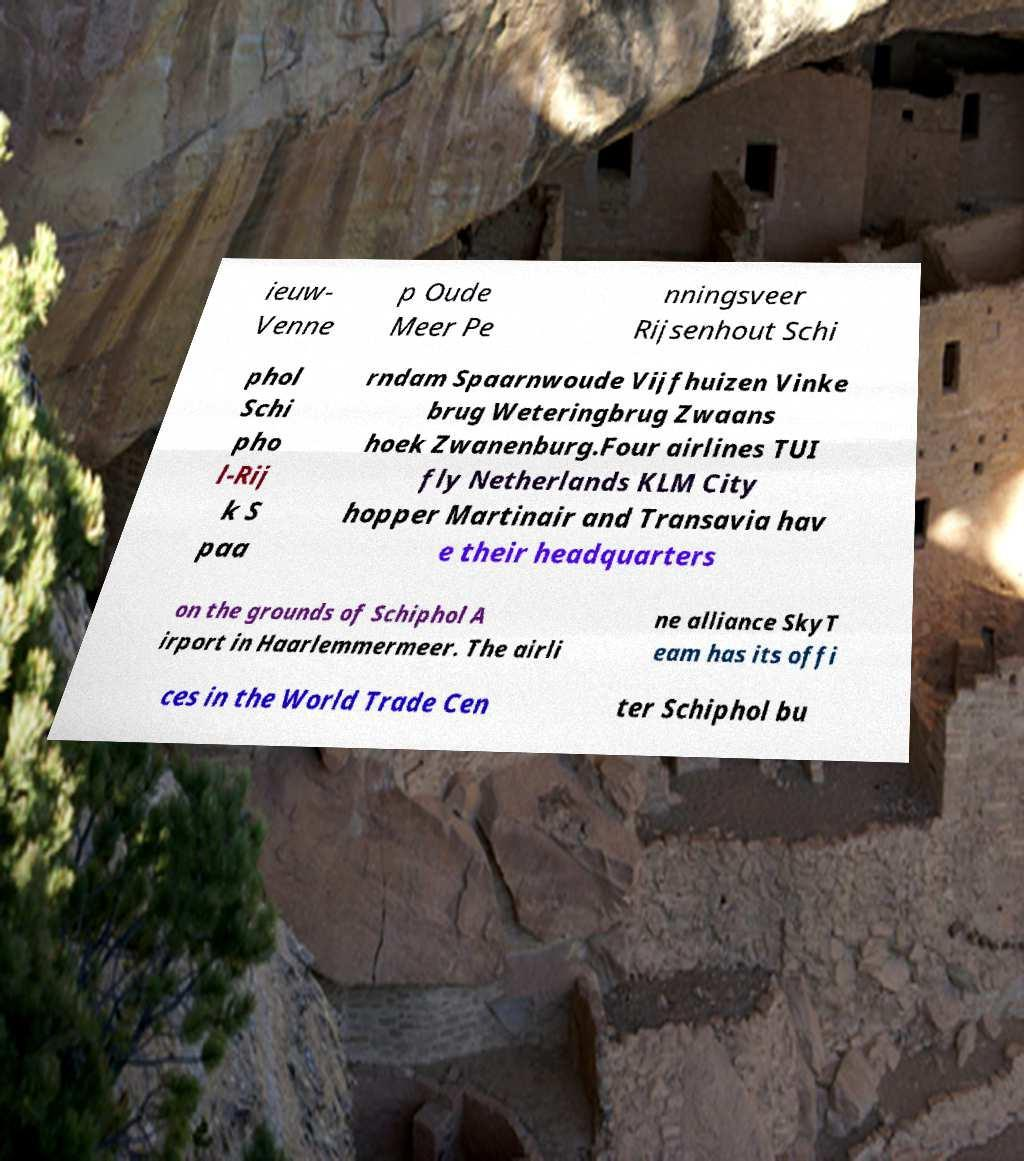For documentation purposes, I need the text within this image transcribed. Could you provide that? ieuw- Venne p Oude Meer Pe nningsveer Rijsenhout Schi phol Schi pho l-Rij k S paa rndam Spaarnwoude Vijfhuizen Vinke brug Weteringbrug Zwaans hoek Zwanenburg.Four airlines TUI fly Netherlands KLM City hopper Martinair and Transavia hav e their headquarters on the grounds of Schiphol A irport in Haarlemmermeer. The airli ne alliance SkyT eam has its offi ces in the World Trade Cen ter Schiphol bu 